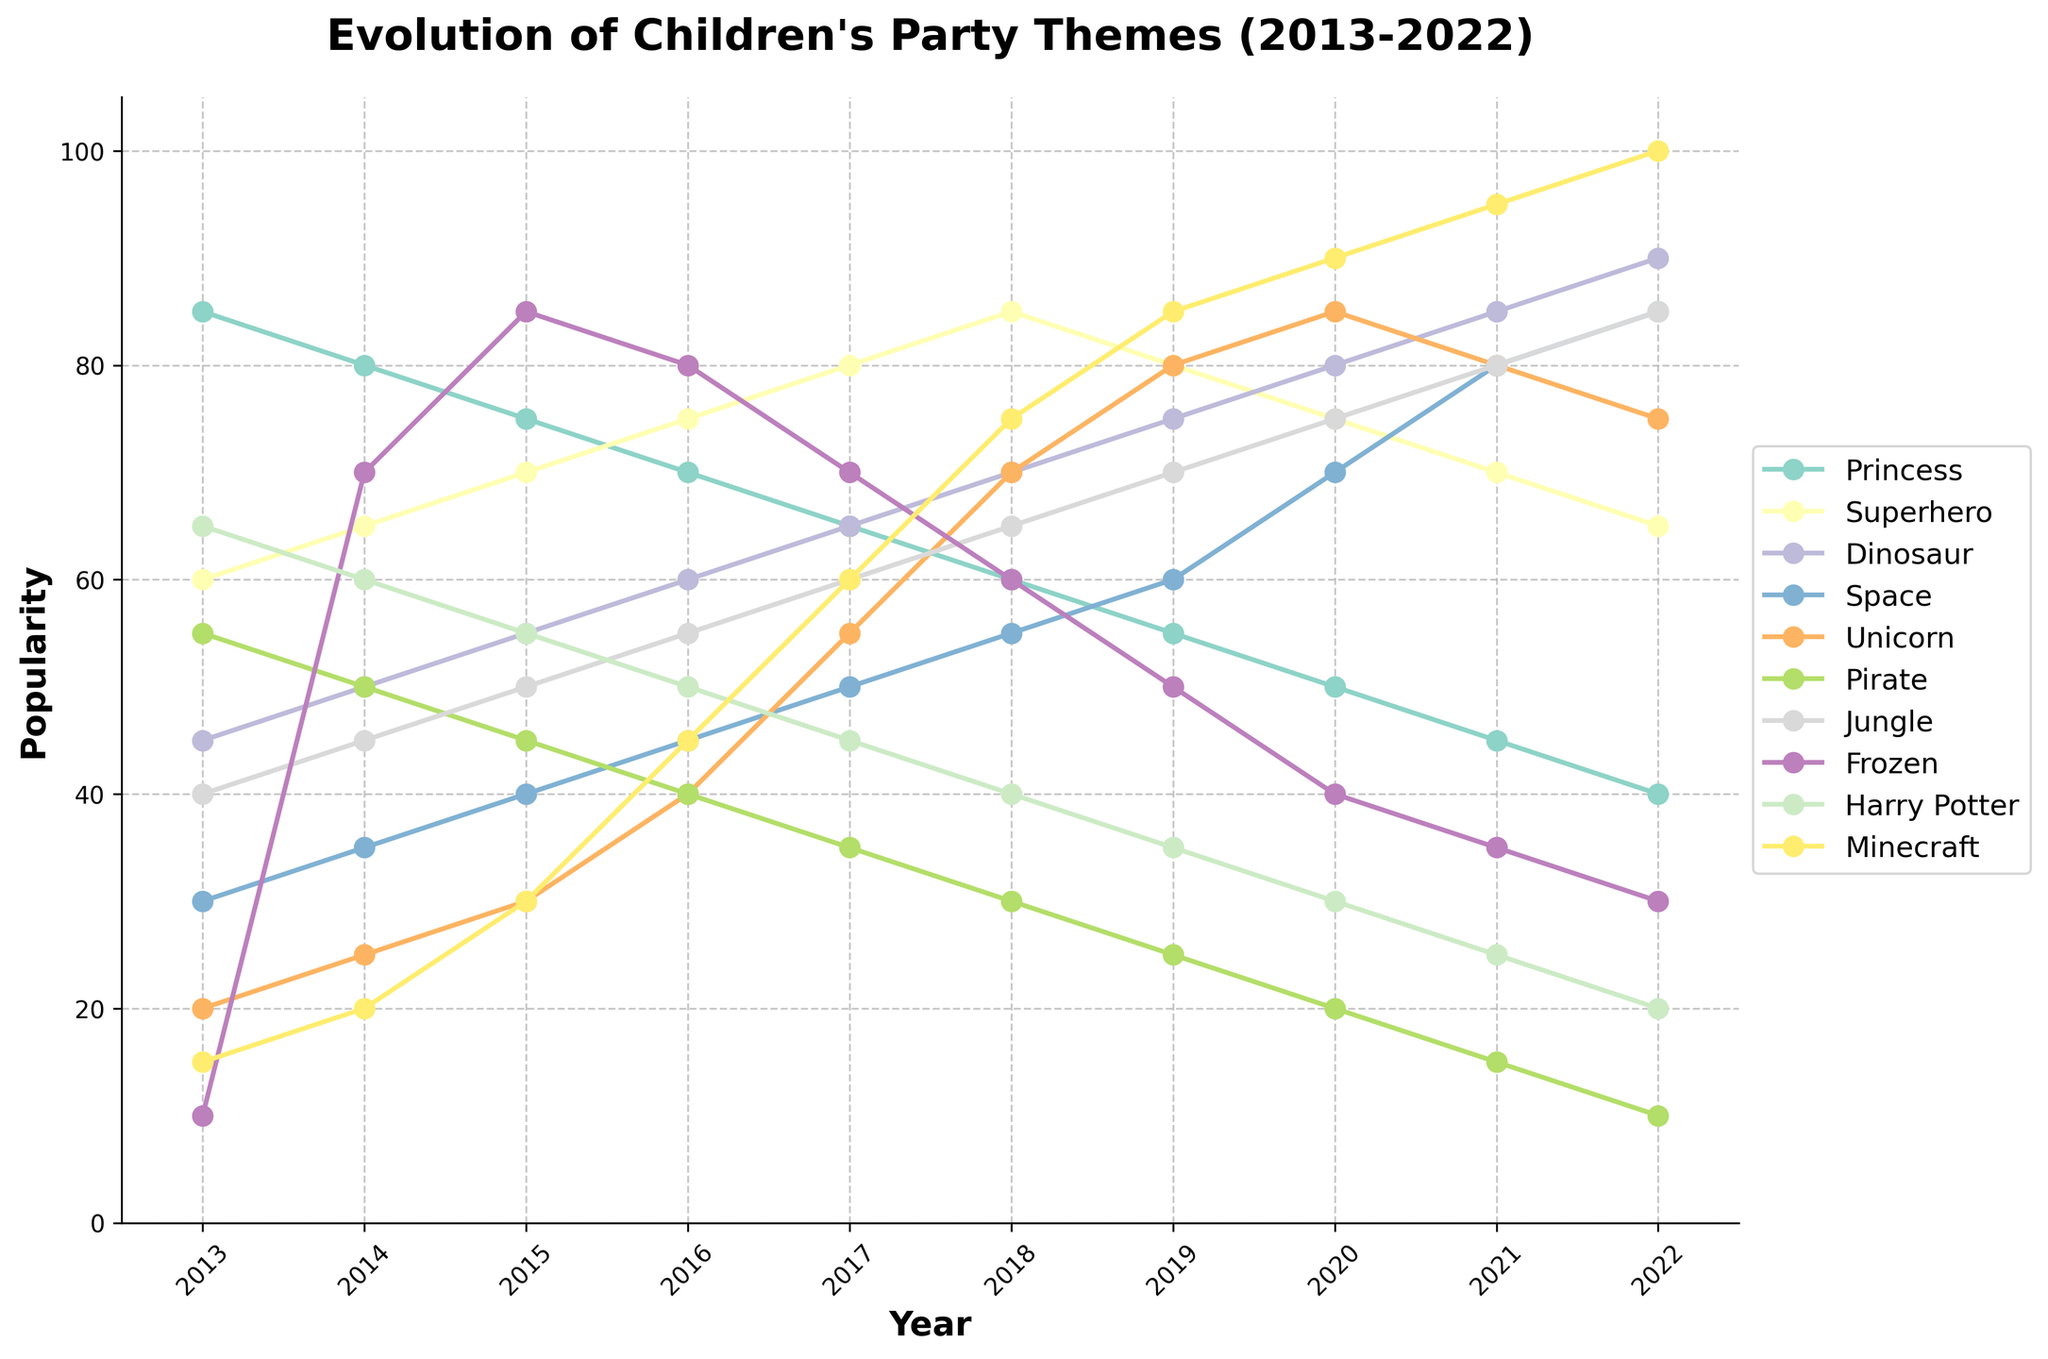Which party theme was the most popular in 2022? Look for the highest point in the 2022 column. The 'Minecraft' theme reaches the highest point.
Answer: Minecraft Which two themes were equally popular in 2013? Look for two lines that intersect at the same point in 2013. The 'Superhero' and 'Frozen' themes both have a popularity of 10 in 2013.
Answer: Superhero and Frozen Between 2016 and 2018, which theme experienced the greatest increase in popularity? Measure the difference in height from 2016 to 2018 for each theme line. The 'Unicorn' theme increased from 40 to 70, which is the largest increase.
Answer: Unicorn How does the 2020 popularity of the 'Dinosaur' theme compare to the 2022 popularity of the 'Space' theme? Locate the 'Dinosaur' theme in 2020 and 'Space' theme in 2022. 'Dinosaur' has 80 in 2020 and 'Space' has 85 in 2022.
Answer: Space is more popular What is the average popularity of the 'Harry Potter' theme over the entire decade? Add up the yearly values for 'Harry Potter' and divide by 10: (65 + 60 + 55 + 50 + 45 + 40 + 35 + 30 + 25 + 20) / 10 = 42.5
Answer: 42.5 Which theme saw a continuous decline in popularity from 2013 to 2022? Look for a line that continuously slopes down from 2013 to 2022. The 'Princess' theme declines every year during this period.
Answer: Princess In which year did the 'Minecraft' theme overtake the 'Frozen' theme in popularity? Find the year where the 'Minecraft' line surpasses the 'Frozen' line. This happens in 2016.
Answer: 2016 Which theme had the lowest popularity in 2021? Identify the theme with the lowest point in the 2021 column. The 'Pirate' theme has the lowest popularity at 15 in 2021.
Answer: Pirate By how much did the 'Space' theme's popularity differ between 2015 and 2020? Calculate the difference in values for the 'Space' theme between 2015 and 2020: 70 - 40 = 30
Answer: 30 What is the second most popular theme in 2018? Find the second highest point in the 2018 column. The 'Superhero' theme is second with 85 after 'Minecraft'.
Answer: Superhero 